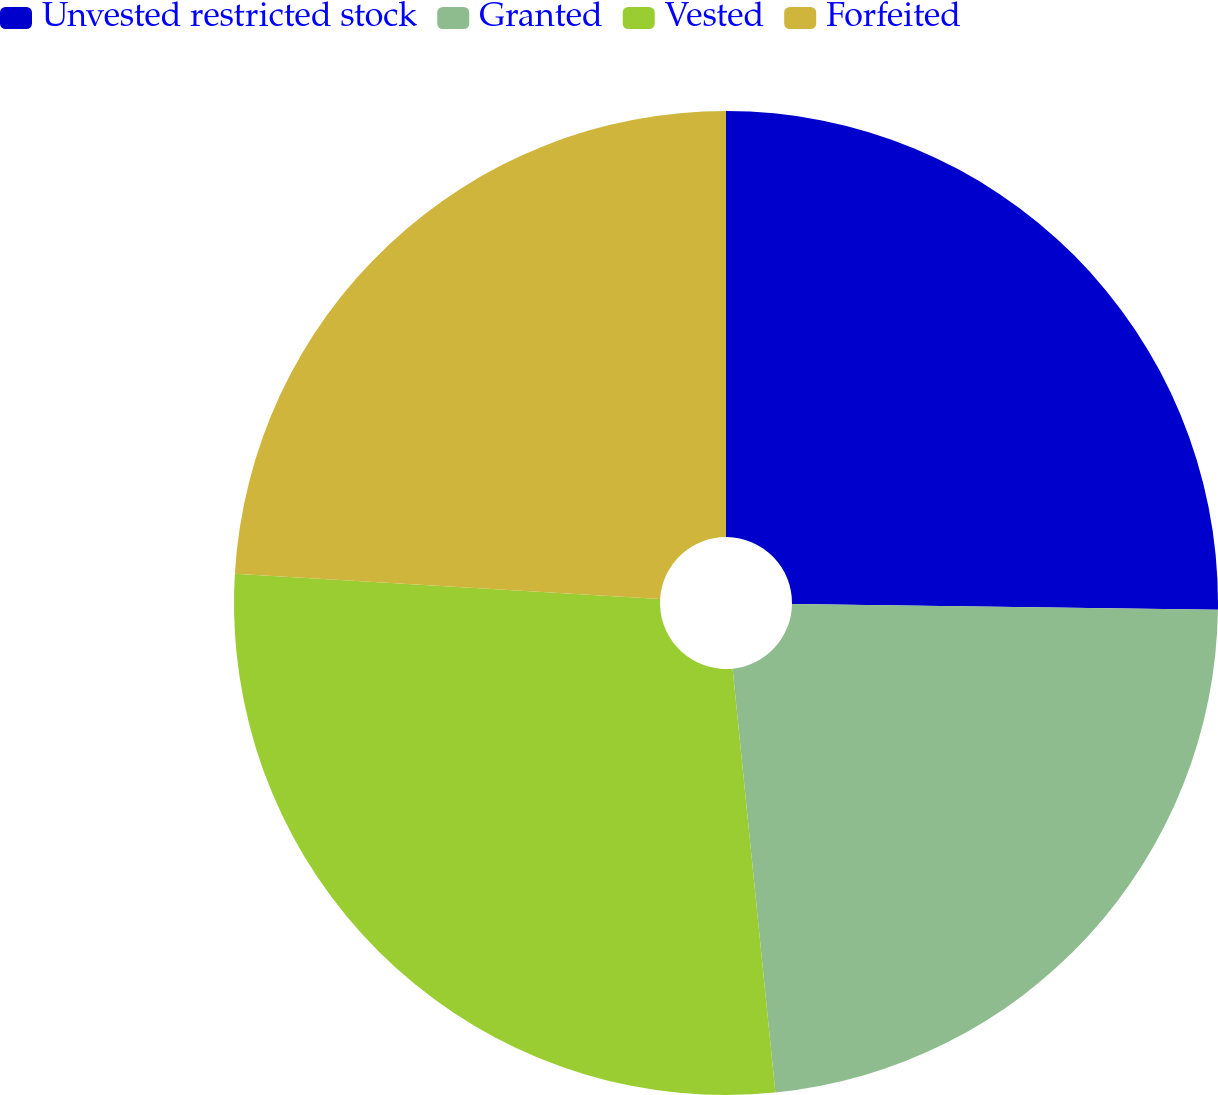<chart> <loc_0><loc_0><loc_500><loc_500><pie_chart><fcel>Unvested restricted stock<fcel>Granted<fcel>Vested<fcel>Forfeited<nl><fcel>25.22%<fcel>23.18%<fcel>27.55%<fcel>24.05%<nl></chart> 